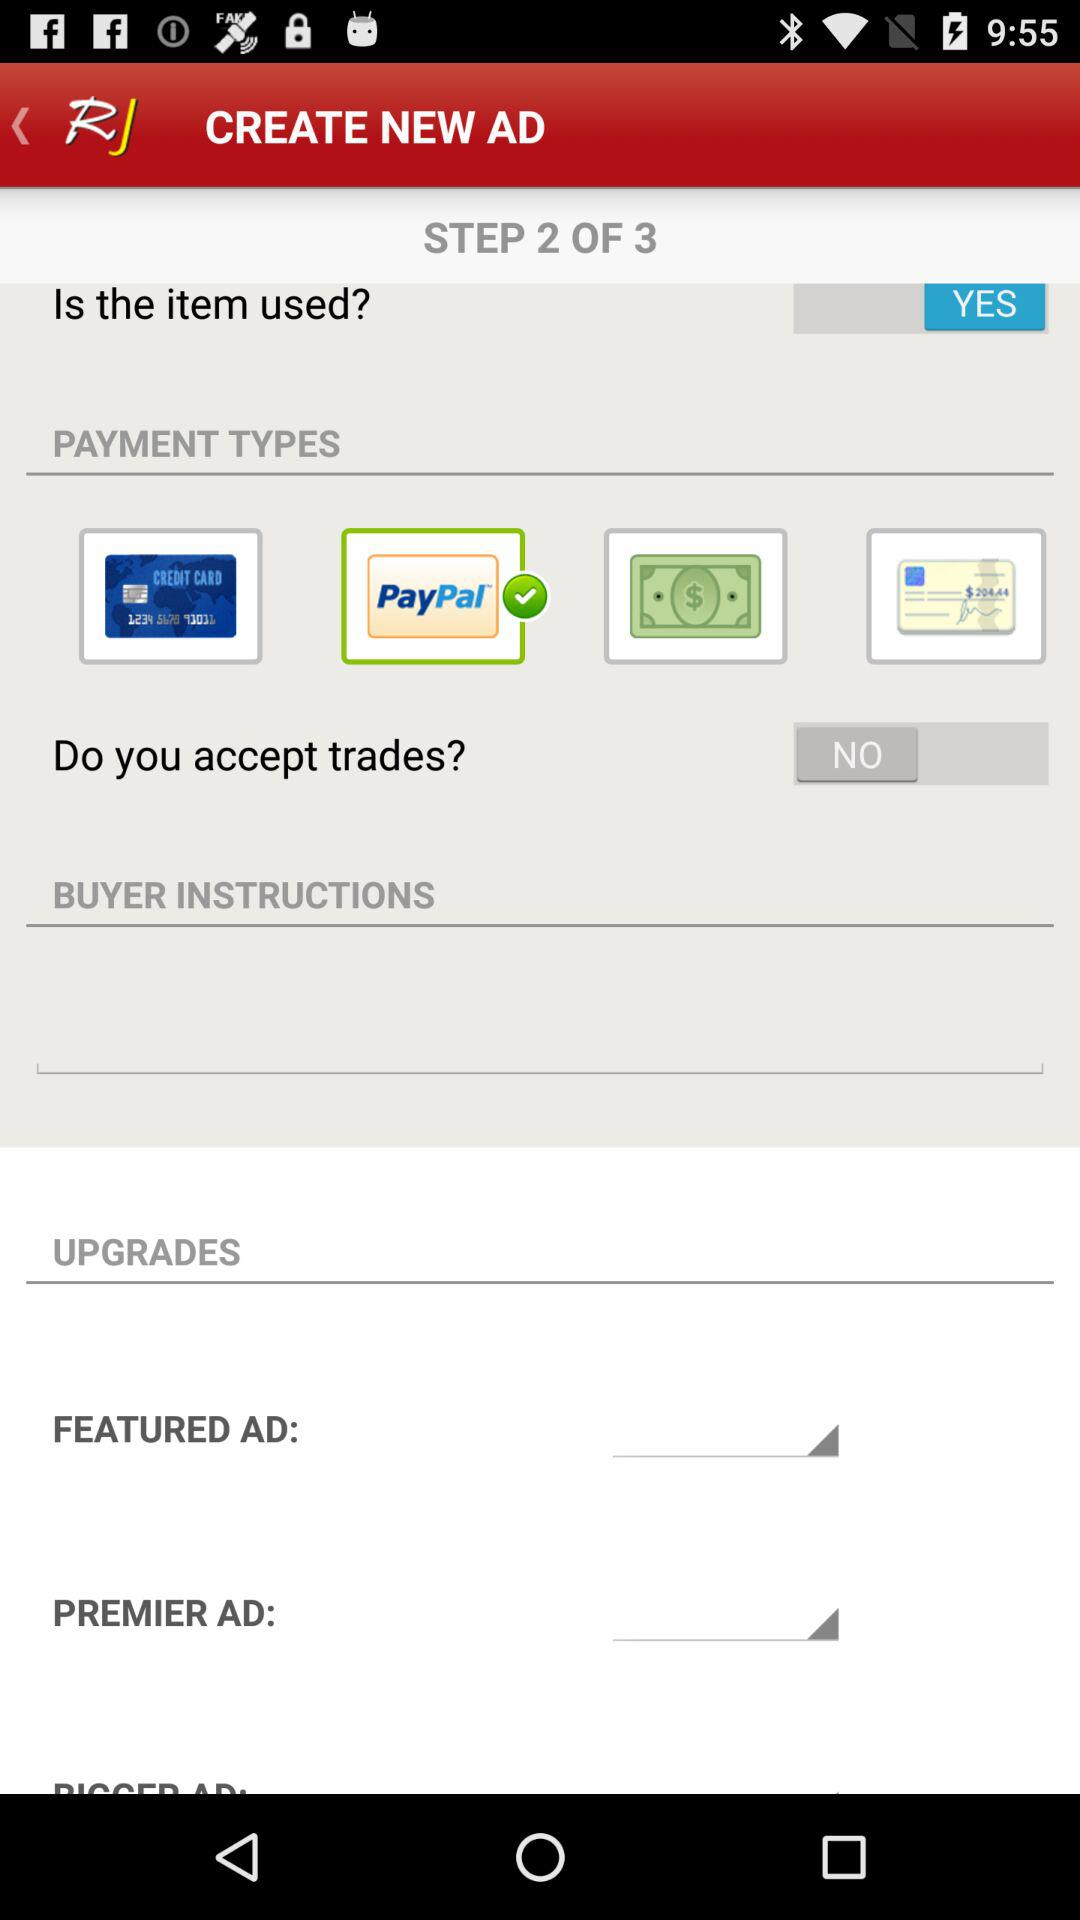How many steps in total are there? There are 3 steps in total. 